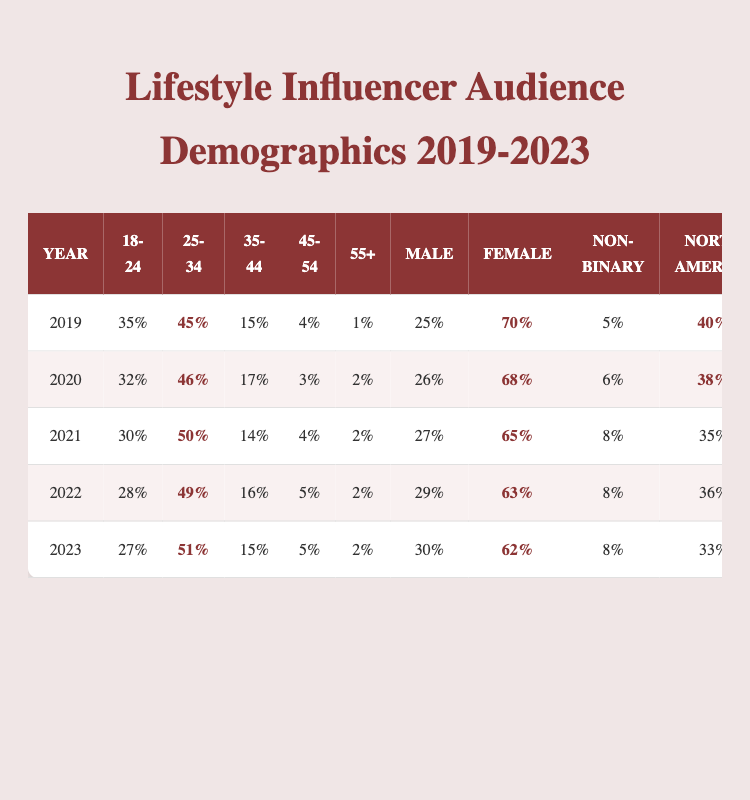What was the highest percentage of the 25-34 age group in any year? The highest percentage for the 25-34 age group is found in 2021 at 50%.
Answer: 50% In which year did the audience demographic for males see the largest increase? Looking at the male percentages, the increase from 2019 (25%) to 2020 (26%) is the largest single-year rise.
Answer: 2020 What is the percentage of the audience that identifies as non-binary in 2023? The non-binary percentage for 2023 is listed as 8%.
Answer: 8% What was the combined percentage of the 18-24 and 35-44 age groups in 2022? In 2022, the percentage of the 18-24 age group is 28%, and for the 35-44 age group, it is 16%. Their combined percentage is 28% + 16% = 44%.
Answer: 44% Is there a trend indicating a decrease in the 45-54 age group from 2019 to 2023? Yes, the percentage for the 45-54 age group has decreased from 4% in 2019 to 5% in 2023, indicating an upward trend; thus, it is misleading as a decline.
Answer: Yes Which year had the highest representation of North American audiences? The year with the highest North American representation is 2019 at 40%.
Answer: 2019 Calculate the average percentage of the female demographic over the five years. The percentages are 70%, 68%, 65%, 63%, and 62%. The sum is 70 + 68 + 65 + 63 + 62 = 328. Thus, the average is 328 / 5 = 65.6%.
Answer: 65.6% What percentage of the audience is aged 55+ in 2021? The percentage for the 55+ age group in 2021 is 2%.
Answer: 2% Did the percentage of the audience from Europe increase or decrease from 2020 to 2021? The percentage for Europe decreased from 31% in 2020 to 30% in 2021.
Answer: Decrease Which year had the lowest percentage of the 18-24 age group? The lowest percentage for the 18-24 age group was in 2023 at 27%.
Answer: 2023 